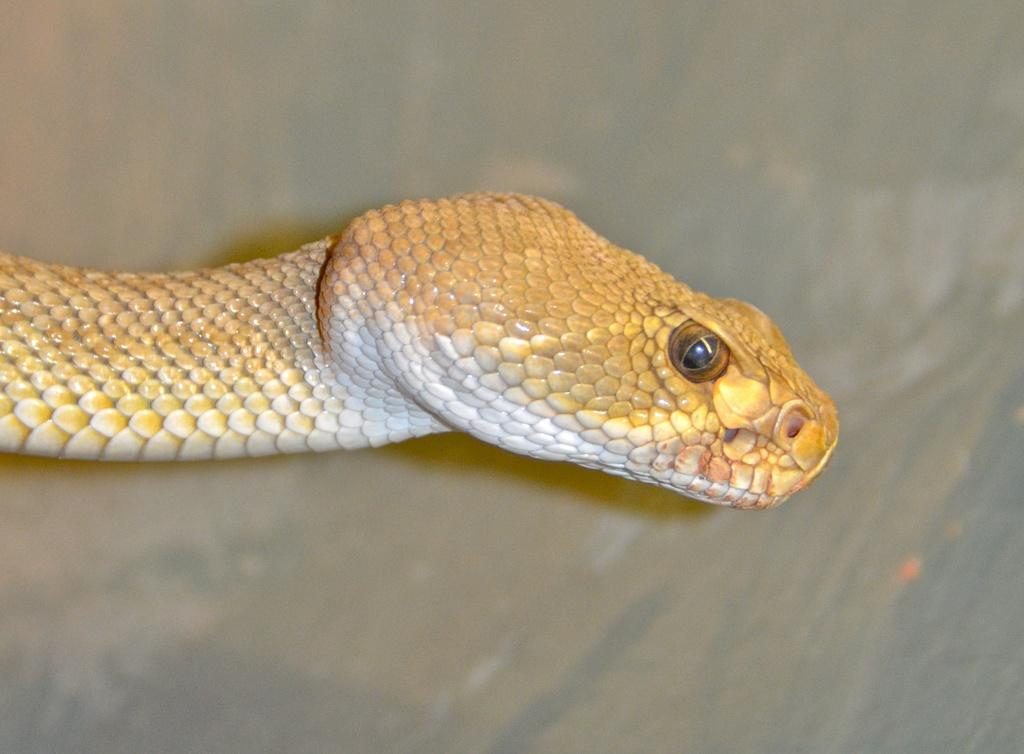What animal is the main subject of the image? There is a snake in the image. Where is the snake located in the image? The snake is in the middle of the image. What type of quartz can be seen in the image? There is no quartz present in the image; it features a snake. How many teeth can be seen on the snake in the image? Snakes do not have teeth like mammals; they have fangs. However, since the snake's mouth is not open in the image, it is impossible to see any fangs. 